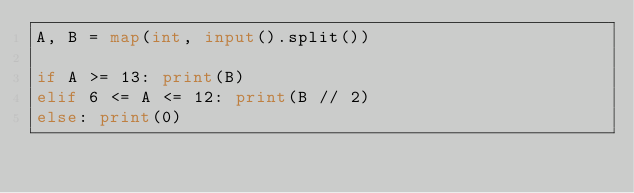<code> <loc_0><loc_0><loc_500><loc_500><_Python_>A, B = map(int, input().split())

if A >= 13: print(B)
elif 6 <= A <= 12: print(B // 2)
else: print(0)</code> 